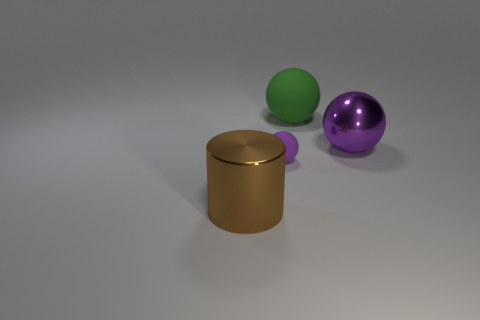Does the large metallic sphere have the same color as the tiny rubber ball?
Provide a short and direct response. Yes. There is a big metallic object that is on the left side of the large matte thing; is there a large thing that is behind it?
Make the answer very short. Yes. What number of tiny purple balls are behind the big metallic cylinder?
Give a very brief answer. 1. There is another metallic thing that is the same shape as the tiny purple thing; what color is it?
Make the answer very short. Purple. Are the ball that is behind the big purple shiny sphere and the purple thing that is in front of the big metallic sphere made of the same material?
Provide a succinct answer. Yes. There is a small thing; does it have the same color as the big ball right of the big green rubber object?
Your answer should be very brief. Yes. What shape is the large thing that is on the left side of the big purple ball and in front of the green sphere?
Offer a very short reply. Cylinder. What number of small purple metallic cylinders are there?
Your response must be concise. 0. There is another metal object that is the same color as the tiny object; what shape is it?
Give a very brief answer. Sphere. What is the size of the other matte object that is the same shape as the big rubber thing?
Ensure brevity in your answer.  Small. 